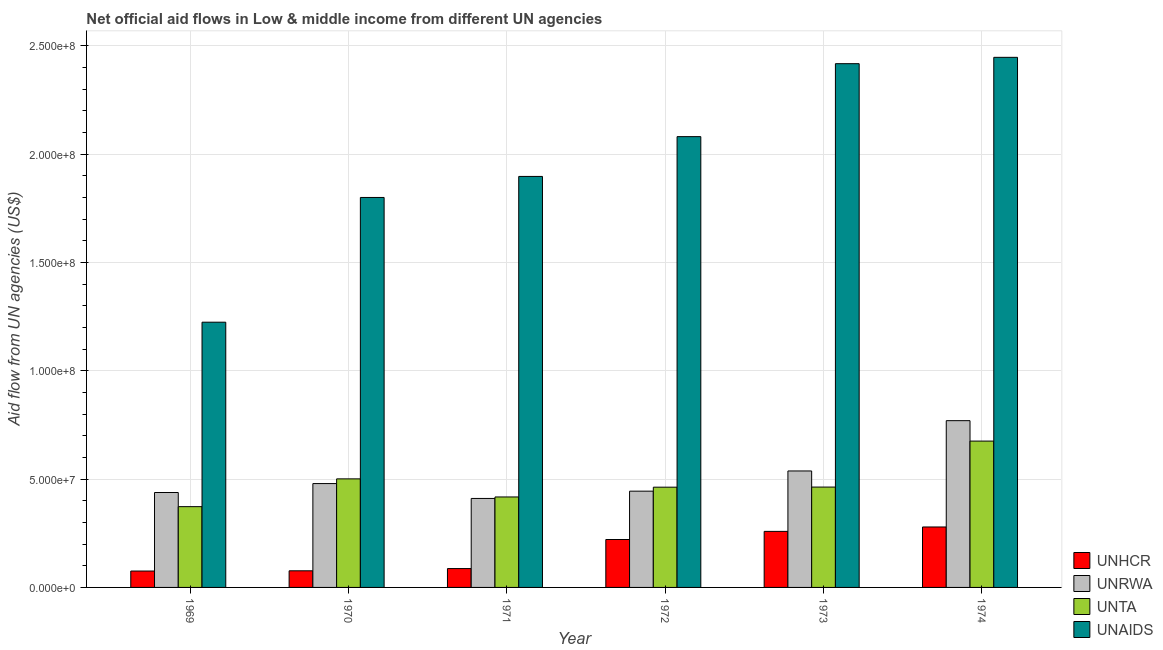How many bars are there on the 6th tick from the left?
Your answer should be compact. 4. What is the label of the 4th group of bars from the left?
Provide a succinct answer. 1972. What is the amount of aid given by unhcr in 1974?
Your answer should be very brief. 2.79e+07. Across all years, what is the maximum amount of aid given by unta?
Your answer should be compact. 6.75e+07. Across all years, what is the minimum amount of aid given by unhcr?
Provide a succinct answer. 7.56e+06. In which year was the amount of aid given by unrwa maximum?
Your response must be concise. 1974. What is the total amount of aid given by unrwa in the graph?
Your answer should be compact. 3.08e+08. What is the difference between the amount of aid given by unrwa in 1969 and that in 1974?
Provide a succinct answer. -3.32e+07. What is the difference between the amount of aid given by unrwa in 1974 and the amount of aid given by unta in 1969?
Offer a terse response. 3.32e+07. What is the average amount of aid given by unta per year?
Your response must be concise. 4.82e+07. In the year 1972, what is the difference between the amount of aid given by unaids and amount of aid given by unta?
Keep it short and to the point. 0. What is the ratio of the amount of aid given by unta in 1969 to that in 1971?
Your response must be concise. 0.89. What is the difference between the highest and the second highest amount of aid given by unaids?
Provide a succinct answer. 2.93e+06. What is the difference between the highest and the lowest amount of aid given by unhcr?
Offer a terse response. 2.03e+07. Is the sum of the amount of aid given by unhcr in 1970 and 1972 greater than the maximum amount of aid given by unaids across all years?
Provide a short and direct response. Yes. What does the 3rd bar from the left in 1969 represents?
Give a very brief answer. UNTA. What does the 3rd bar from the right in 1972 represents?
Provide a short and direct response. UNRWA. Is it the case that in every year, the sum of the amount of aid given by unhcr and amount of aid given by unrwa is greater than the amount of aid given by unta?
Ensure brevity in your answer.  Yes. Are the values on the major ticks of Y-axis written in scientific E-notation?
Your answer should be very brief. Yes. How many legend labels are there?
Offer a terse response. 4. What is the title of the graph?
Provide a short and direct response. Net official aid flows in Low & middle income from different UN agencies. What is the label or title of the Y-axis?
Your answer should be compact. Aid flow from UN agencies (US$). What is the Aid flow from UN agencies (US$) of UNHCR in 1969?
Your answer should be compact. 7.56e+06. What is the Aid flow from UN agencies (US$) of UNRWA in 1969?
Provide a short and direct response. 4.38e+07. What is the Aid flow from UN agencies (US$) of UNTA in 1969?
Keep it short and to the point. 3.73e+07. What is the Aid flow from UN agencies (US$) of UNAIDS in 1969?
Offer a terse response. 1.22e+08. What is the Aid flow from UN agencies (US$) of UNHCR in 1970?
Offer a terse response. 7.67e+06. What is the Aid flow from UN agencies (US$) of UNRWA in 1970?
Offer a very short reply. 4.79e+07. What is the Aid flow from UN agencies (US$) in UNTA in 1970?
Make the answer very short. 5.01e+07. What is the Aid flow from UN agencies (US$) in UNAIDS in 1970?
Ensure brevity in your answer.  1.80e+08. What is the Aid flow from UN agencies (US$) of UNHCR in 1971?
Your answer should be compact. 8.70e+06. What is the Aid flow from UN agencies (US$) in UNRWA in 1971?
Make the answer very short. 4.11e+07. What is the Aid flow from UN agencies (US$) of UNTA in 1971?
Give a very brief answer. 4.18e+07. What is the Aid flow from UN agencies (US$) in UNAIDS in 1971?
Your answer should be very brief. 1.90e+08. What is the Aid flow from UN agencies (US$) of UNHCR in 1972?
Your response must be concise. 2.21e+07. What is the Aid flow from UN agencies (US$) in UNRWA in 1972?
Provide a short and direct response. 4.44e+07. What is the Aid flow from UN agencies (US$) in UNTA in 1972?
Give a very brief answer. 4.63e+07. What is the Aid flow from UN agencies (US$) in UNAIDS in 1972?
Provide a short and direct response. 2.08e+08. What is the Aid flow from UN agencies (US$) in UNHCR in 1973?
Keep it short and to the point. 2.59e+07. What is the Aid flow from UN agencies (US$) of UNRWA in 1973?
Provide a succinct answer. 5.38e+07. What is the Aid flow from UN agencies (US$) in UNTA in 1973?
Your response must be concise. 4.63e+07. What is the Aid flow from UN agencies (US$) in UNAIDS in 1973?
Ensure brevity in your answer.  2.42e+08. What is the Aid flow from UN agencies (US$) of UNHCR in 1974?
Your answer should be very brief. 2.79e+07. What is the Aid flow from UN agencies (US$) of UNRWA in 1974?
Provide a short and direct response. 7.70e+07. What is the Aid flow from UN agencies (US$) in UNTA in 1974?
Keep it short and to the point. 6.75e+07. What is the Aid flow from UN agencies (US$) of UNAIDS in 1974?
Make the answer very short. 2.45e+08. Across all years, what is the maximum Aid flow from UN agencies (US$) in UNHCR?
Give a very brief answer. 2.79e+07. Across all years, what is the maximum Aid flow from UN agencies (US$) of UNRWA?
Offer a very short reply. 7.70e+07. Across all years, what is the maximum Aid flow from UN agencies (US$) in UNTA?
Your answer should be very brief. 6.75e+07. Across all years, what is the maximum Aid flow from UN agencies (US$) in UNAIDS?
Provide a short and direct response. 2.45e+08. Across all years, what is the minimum Aid flow from UN agencies (US$) in UNHCR?
Give a very brief answer. 7.56e+06. Across all years, what is the minimum Aid flow from UN agencies (US$) in UNRWA?
Ensure brevity in your answer.  4.11e+07. Across all years, what is the minimum Aid flow from UN agencies (US$) of UNTA?
Offer a very short reply. 3.73e+07. Across all years, what is the minimum Aid flow from UN agencies (US$) in UNAIDS?
Ensure brevity in your answer.  1.22e+08. What is the total Aid flow from UN agencies (US$) of UNHCR in the graph?
Your response must be concise. 9.98e+07. What is the total Aid flow from UN agencies (US$) of UNRWA in the graph?
Give a very brief answer. 3.08e+08. What is the total Aid flow from UN agencies (US$) in UNTA in the graph?
Your answer should be very brief. 2.89e+08. What is the total Aid flow from UN agencies (US$) of UNAIDS in the graph?
Keep it short and to the point. 1.19e+09. What is the difference between the Aid flow from UN agencies (US$) of UNRWA in 1969 and that in 1970?
Offer a very short reply. -4.13e+06. What is the difference between the Aid flow from UN agencies (US$) in UNTA in 1969 and that in 1970?
Your answer should be very brief. -1.28e+07. What is the difference between the Aid flow from UN agencies (US$) of UNAIDS in 1969 and that in 1970?
Offer a very short reply. -5.76e+07. What is the difference between the Aid flow from UN agencies (US$) of UNHCR in 1969 and that in 1971?
Make the answer very short. -1.14e+06. What is the difference between the Aid flow from UN agencies (US$) of UNRWA in 1969 and that in 1971?
Provide a succinct answer. 2.74e+06. What is the difference between the Aid flow from UN agencies (US$) in UNTA in 1969 and that in 1971?
Your answer should be compact. -4.47e+06. What is the difference between the Aid flow from UN agencies (US$) of UNAIDS in 1969 and that in 1971?
Your answer should be very brief. -6.73e+07. What is the difference between the Aid flow from UN agencies (US$) in UNHCR in 1969 and that in 1972?
Provide a short and direct response. -1.46e+07. What is the difference between the Aid flow from UN agencies (US$) of UNRWA in 1969 and that in 1972?
Make the answer very short. -6.20e+05. What is the difference between the Aid flow from UN agencies (US$) in UNTA in 1969 and that in 1972?
Ensure brevity in your answer.  -8.98e+06. What is the difference between the Aid flow from UN agencies (US$) in UNAIDS in 1969 and that in 1972?
Provide a succinct answer. -8.56e+07. What is the difference between the Aid flow from UN agencies (US$) in UNHCR in 1969 and that in 1973?
Provide a succinct answer. -1.83e+07. What is the difference between the Aid flow from UN agencies (US$) in UNRWA in 1969 and that in 1973?
Ensure brevity in your answer.  -9.95e+06. What is the difference between the Aid flow from UN agencies (US$) of UNTA in 1969 and that in 1973?
Your answer should be very brief. -9.03e+06. What is the difference between the Aid flow from UN agencies (US$) in UNAIDS in 1969 and that in 1973?
Your response must be concise. -1.19e+08. What is the difference between the Aid flow from UN agencies (US$) of UNHCR in 1969 and that in 1974?
Ensure brevity in your answer.  -2.03e+07. What is the difference between the Aid flow from UN agencies (US$) of UNRWA in 1969 and that in 1974?
Provide a short and direct response. -3.32e+07. What is the difference between the Aid flow from UN agencies (US$) of UNTA in 1969 and that in 1974?
Your response must be concise. -3.02e+07. What is the difference between the Aid flow from UN agencies (US$) of UNAIDS in 1969 and that in 1974?
Provide a short and direct response. -1.22e+08. What is the difference between the Aid flow from UN agencies (US$) in UNHCR in 1970 and that in 1971?
Make the answer very short. -1.03e+06. What is the difference between the Aid flow from UN agencies (US$) in UNRWA in 1970 and that in 1971?
Your answer should be compact. 6.87e+06. What is the difference between the Aid flow from UN agencies (US$) in UNTA in 1970 and that in 1971?
Your answer should be very brief. 8.35e+06. What is the difference between the Aid flow from UN agencies (US$) in UNAIDS in 1970 and that in 1971?
Your answer should be compact. -9.71e+06. What is the difference between the Aid flow from UN agencies (US$) of UNHCR in 1970 and that in 1972?
Make the answer very short. -1.44e+07. What is the difference between the Aid flow from UN agencies (US$) in UNRWA in 1970 and that in 1972?
Ensure brevity in your answer.  3.51e+06. What is the difference between the Aid flow from UN agencies (US$) in UNTA in 1970 and that in 1972?
Make the answer very short. 3.84e+06. What is the difference between the Aid flow from UN agencies (US$) of UNAIDS in 1970 and that in 1972?
Ensure brevity in your answer.  -2.81e+07. What is the difference between the Aid flow from UN agencies (US$) in UNHCR in 1970 and that in 1973?
Your answer should be compact. -1.82e+07. What is the difference between the Aid flow from UN agencies (US$) of UNRWA in 1970 and that in 1973?
Your answer should be compact. -5.82e+06. What is the difference between the Aid flow from UN agencies (US$) of UNTA in 1970 and that in 1973?
Keep it short and to the point. 3.79e+06. What is the difference between the Aid flow from UN agencies (US$) in UNAIDS in 1970 and that in 1973?
Offer a very short reply. -6.17e+07. What is the difference between the Aid flow from UN agencies (US$) in UNHCR in 1970 and that in 1974?
Keep it short and to the point. -2.02e+07. What is the difference between the Aid flow from UN agencies (US$) in UNRWA in 1970 and that in 1974?
Your answer should be compact. -2.90e+07. What is the difference between the Aid flow from UN agencies (US$) of UNTA in 1970 and that in 1974?
Ensure brevity in your answer.  -1.74e+07. What is the difference between the Aid flow from UN agencies (US$) of UNAIDS in 1970 and that in 1974?
Offer a very short reply. -6.47e+07. What is the difference between the Aid flow from UN agencies (US$) of UNHCR in 1971 and that in 1972?
Keep it short and to the point. -1.34e+07. What is the difference between the Aid flow from UN agencies (US$) of UNRWA in 1971 and that in 1972?
Offer a terse response. -3.36e+06. What is the difference between the Aid flow from UN agencies (US$) in UNTA in 1971 and that in 1972?
Offer a terse response. -4.51e+06. What is the difference between the Aid flow from UN agencies (US$) in UNAIDS in 1971 and that in 1972?
Ensure brevity in your answer.  -1.84e+07. What is the difference between the Aid flow from UN agencies (US$) of UNHCR in 1971 and that in 1973?
Keep it short and to the point. -1.72e+07. What is the difference between the Aid flow from UN agencies (US$) in UNRWA in 1971 and that in 1973?
Your answer should be very brief. -1.27e+07. What is the difference between the Aid flow from UN agencies (US$) in UNTA in 1971 and that in 1973?
Provide a succinct answer. -4.56e+06. What is the difference between the Aid flow from UN agencies (US$) of UNAIDS in 1971 and that in 1973?
Give a very brief answer. -5.20e+07. What is the difference between the Aid flow from UN agencies (US$) of UNHCR in 1971 and that in 1974?
Offer a terse response. -1.92e+07. What is the difference between the Aid flow from UN agencies (US$) of UNRWA in 1971 and that in 1974?
Offer a very short reply. -3.59e+07. What is the difference between the Aid flow from UN agencies (US$) of UNTA in 1971 and that in 1974?
Ensure brevity in your answer.  -2.58e+07. What is the difference between the Aid flow from UN agencies (US$) of UNAIDS in 1971 and that in 1974?
Your response must be concise. -5.50e+07. What is the difference between the Aid flow from UN agencies (US$) in UNHCR in 1972 and that in 1973?
Provide a succinct answer. -3.75e+06. What is the difference between the Aid flow from UN agencies (US$) of UNRWA in 1972 and that in 1973?
Offer a terse response. -9.33e+06. What is the difference between the Aid flow from UN agencies (US$) in UNTA in 1972 and that in 1973?
Provide a succinct answer. -5.00e+04. What is the difference between the Aid flow from UN agencies (US$) of UNAIDS in 1972 and that in 1973?
Give a very brief answer. -3.37e+07. What is the difference between the Aid flow from UN agencies (US$) in UNHCR in 1972 and that in 1974?
Provide a short and direct response. -5.79e+06. What is the difference between the Aid flow from UN agencies (US$) of UNRWA in 1972 and that in 1974?
Provide a short and direct response. -3.25e+07. What is the difference between the Aid flow from UN agencies (US$) in UNTA in 1972 and that in 1974?
Make the answer very short. -2.13e+07. What is the difference between the Aid flow from UN agencies (US$) of UNAIDS in 1972 and that in 1974?
Your answer should be very brief. -3.66e+07. What is the difference between the Aid flow from UN agencies (US$) in UNHCR in 1973 and that in 1974?
Provide a short and direct response. -2.04e+06. What is the difference between the Aid flow from UN agencies (US$) of UNRWA in 1973 and that in 1974?
Offer a very short reply. -2.32e+07. What is the difference between the Aid flow from UN agencies (US$) of UNTA in 1973 and that in 1974?
Your answer should be compact. -2.12e+07. What is the difference between the Aid flow from UN agencies (US$) of UNAIDS in 1973 and that in 1974?
Ensure brevity in your answer.  -2.93e+06. What is the difference between the Aid flow from UN agencies (US$) of UNHCR in 1969 and the Aid flow from UN agencies (US$) of UNRWA in 1970?
Your answer should be very brief. -4.04e+07. What is the difference between the Aid flow from UN agencies (US$) in UNHCR in 1969 and the Aid flow from UN agencies (US$) in UNTA in 1970?
Ensure brevity in your answer.  -4.25e+07. What is the difference between the Aid flow from UN agencies (US$) of UNHCR in 1969 and the Aid flow from UN agencies (US$) of UNAIDS in 1970?
Offer a terse response. -1.72e+08. What is the difference between the Aid flow from UN agencies (US$) in UNRWA in 1969 and the Aid flow from UN agencies (US$) in UNTA in 1970?
Your response must be concise. -6.30e+06. What is the difference between the Aid flow from UN agencies (US$) of UNRWA in 1969 and the Aid flow from UN agencies (US$) of UNAIDS in 1970?
Your answer should be compact. -1.36e+08. What is the difference between the Aid flow from UN agencies (US$) of UNTA in 1969 and the Aid flow from UN agencies (US$) of UNAIDS in 1970?
Your answer should be compact. -1.43e+08. What is the difference between the Aid flow from UN agencies (US$) of UNHCR in 1969 and the Aid flow from UN agencies (US$) of UNRWA in 1971?
Make the answer very short. -3.35e+07. What is the difference between the Aid flow from UN agencies (US$) of UNHCR in 1969 and the Aid flow from UN agencies (US$) of UNTA in 1971?
Provide a succinct answer. -3.42e+07. What is the difference between the Aid flow from UN agencies (US$) in UNHCR in 1969 and the Aid flow from UN agencies (US$) in UNAIDS in 1971?
Give a very brief answer. -1.82e+08. What is the difference between the Aid flow from UN agencies (US$) of UNRWA in 1969 and the Aid flow from UN agencies (US$) of UNTA in 1971?
Give a very brief answer. 2.05e+06. What is the difference between the Aid flow from UN agencies (US$) in UNRWA in 1969 and the Aid flow from UN agencies (US$) in UNAIDS in 1971?
Your answer should be very brief. -1.46e+08. What is the difference between the Aid flow from UN agencies (US$) in UNTA in 1969 and the Aid flow from UN agencies (US$) in UNAIDS in 1971?
Give a very brief answer. -1.52e+08. What is the difference between the Aid flow from UN agencies (US$) of UNHCR in 1969 and the Aid flow from UN agencies (US$) of UNRWA in 1972?
Make the answer very short. -3.69e+07. What is the difference between the Aid flow from UN agencies (US$) in UNHCR in 1969 and the Aid flow from UN agencies (US$) in UNTA in 1972?
Your answer should be compact. -3.87e+07. What is the difference between the Aid flow from UN agencies (US$) of UNHCR in 1969 and the Aid flow from UN agencies (US$) of UNAIDS in 1972?
Provide a short and direct response. -2.00e+08. What is the difference between the Aid flow from UN agencies (US$) in UNRWA in 1969 and the Aid flow from UN agencies (US$) in UNTA in 1972?
Give a very brief answer. -2.46e+06. What is the difference between the Aid flow from UN agencies (US$) of UNRWA in 1969 and the Aid flow from UN agencies (US$) of UNAIDS in 1972?
Your answer should be compact. -1.64e+08. What is the difference between the Aid flow from UN agencies (US$) of UNTA in 1969 and the Aid flow from UN agencies (US$) of UNAIDS in 1972?
Provide a short and direct response. -1.71e+08. What is the difference between the Aid flow from UN agencies (US$) of UNHCR in 1969 and the Aid flow from UN agencies (US$) of UNRWA in 1973?
Offer a very short reply. -4.62e+07. What is the difference between the Aid flow from UN agencies (US$) in UNHCR in 1969 and the Aid flow from UN agencies (US$) in UNTA in 1973?
Your answer should be compact. -3.88e+07. What is the difference between the Aid flow from UN agencies (US$) in UNHCR in 1969 and the Aid flow from UN agencies (US$) in UNAIDS in 1973?
Provide a short and direct response. -2.34e+08. What is the difference between the Aid flow from UN agencies (US$) in UNRWA in 1969 and the Aid flow from UN agencies (US$) in UNTA in 1973?
Provide a short and direct response. -2.51e+06. What is the difference between the Aid flow from UN agencies (US$) in UNRWA in 1969 and the Aid flow from UN agencies (US$) in UNAIDS in 1973?
Ensure brevity in your answer.  -1.98e+08. What is the difference between the Aid flow from UN agencies (US$) of UNTA in 1969 and the Aid flow from UN agencies (US$) of UNAIDS in 1973?
Offer a very short reply. -2.04e+08. What is the difference between the Aid flow from UN agencies (US$) of UNHCR in 1969 and the Aid flow from UN agencies (US$) of UNRWA in 1974?
Keep it short and to the point. -6.94e+07. What is the difference between the Aid flow from UN agencies (US$) in UNHCR in 1969 and the Aid flow from UN agencies (US$) in UNTA in 1974?
Offer a very short reply. -6.00e+07. What is the difference between the Aid flow from UN agencies (US$) of UNHCR in 1969 and the Aid flow from UN agencies (US$) of UNAIDS in 1974?
Give a very brief answer. -2.37e+08. What is the difference between the Aid flow from UN agencies (US$) in UNRWA in 1969 and the Aid flow from UN agencies (US$) in UNTA in 1974?
Keep it short and to the point. -2.37e+07. What is the difference between the Aid flow from UN agencies (US$) of UNRWA in 1969 and the Aid flow from UN agencies (US$) of UNAIDS in 1974?
Make the answer very short. -2.01e+08. What is the difference between the Aid flow from UN agencies (US$) of UNTA in 1969 and the Aid flow from UN agencies (US$) of UNAIDS in 1974?
Your response must be concise. -2.07e+08. What is the difference between the Aid flow from UN agencies (US$) in UNHCR in 1970 and the Aid flow from UN agencies (US$) in UNRWA in 1971?
Your answer should be very brief. -3.34e+07. What is the difference between the Aid flow from UN agencies (US$) of UNHCR in 1970 and the Aid flow from UN agencies (US$) of UNTA in 1971?
Your answer should be very brief. -3.41e+07. What is the difference between the Aid flow from UN agencies (US$) in UNHCR in 1970 and the Aid flow from UN agencies (US$) in UNAIDS in 1971?
Make the answer very short. -1.82e+08. What is the difference between the Aid flow from UN agencies (US$) of UNRWA in 1970 and the Aid flow from UN agencies (US$) of UNTA in 1971?
Provide a short and direct response. 6.18e+06. What is the difference between the Aid flow from UN agencies (US$) of UNRWA in 1970 and the Aid flow from UN agencies (US$) of UNAIDS in 1971?
Ensure brevity in your answer.  -1.42e+08. What is the difference between the Aid flow from UN agencies (US$) in UNTA in 1970 and the Aid flow from UN agencies (US$) in UNAIDS in 1971?
Ensure brevity in your answer.  -1.40e+08. What is the difference between the Aid flow from UN agencies (US$) of UNHCR in 1970 and the Aid flow from UN agencies (US$) of UNRWA in 1972?
Your response must be concise. -3.68e+07. What is the difference between the Aid flow from UN agencies (US$) of UNHCR in 1970 and the Aid flow from UN agencies (US$) of UNTA in 1972?
Offer a very short reply. -3.86e+07. What is the difference between the Aid flow from UN agencies (US$) of UNHCR in 1970 and the Aid flow from UN agencies (US$) of UNAIDS in 1972?
Provide a succinct answer. -2.00e+08. What is the difference between the Aid flow from UN agencies (US$) in UNRWA in 1970 and the Aid flow from UN agencies (US$) in UNTA in 1972?
Your answer should be very brief. 1.67e+06. What is the difference between the Aid flow from UN agencies (US$) in UNRWA in 1970 and the Aid flow from UN agencies (US$) in UNAIDS in 1972?
Your answer should be compact. -1.60e+08. What is the difference between the Aid flow from UN agencies (US$) in UNTA in 1970 and the Aid flow from UN agencies (US$) in UNAIDS in 1972?
Give a very brief answer. -1.58e+08. What is the difference between the Aid flow from UN agencies (US$) of UNHCR in 1970 and the Aid flow from UN agencies (US$) of UNRWA in 1973?
Provide a short and direct response. -4.61e+07. What is the difference between the Aid flow from UN agencies (US$) in UNHCR in 1970 and the Aid flow from UN agencies (US$) in UNTA in 1973?
Your answer should be compact. -3.86e+07. What is the difference between the Aid flow from UN agencies (US$) of UNHCR in 1970 and the Aid flow from UN agencies (US$) of UNAIDS in 1973?
Offer a terse response. -2.34e+08. What is the difference between the Aid flow from UN agencies (US$) in UNRWA in 1970 and the Aid flow from UN agencies (US$) in UNTA in 1973?
Your answer should be very brief. 1.62e+06. What is the difference between the Aid flow from UN agencies (US$) of UNRWA in 1970 and the Aid flow from UN agencies (US$) of UNAIDS in 1973?
Your response must be concise. -1.94e+08. What is the difference between the Aid flow from UN agencies (US$) of UNTA in 1970 and the Aid flow from UN agencies (US$) of UNAIDS in 1973?
Your answer should be very brief. -1.92e+08. What is the difference between the Aid flow from UN agencies (US$) in UNHCR in 1970 and the Aid flow from UN agencies (US$) in UNRWA in 1974?
Give a very brief answer. -6.93e+07. What is the difference between the Aid flow from UN agencies (US$) of UNHCR in 1970 and the Aid flow from UN agencies (US$) of UNTA in 1974?
Provide a short and direct response. -5.99e+07. What is the difference between the Aid flow from UN agencies (US$) of UNHCR in 1970 and the Aid flow from UN agencies (US$) of UNAIDS in 1974?
Give a very brief answer. -2.37e+08. What is the difference between the Aid flow from UN agencies (US$) in UNRWA in 1970 and the Aid flow from UN agencies (US$) in UNTA in 1974?
Your answer should be very brief. -1.96e+07. What is the difference between the Aid flow from UN agencies (US$) in UNRWA in 1970 and the Aid flow from UN agencies (US$) in UNAIDS in 1974?
Provide a succinct answer. -1.97e+08. What is the difference between the Aid flow from UN agencies (US$) in UNTA in 1970 and the Aid flow from UN agencies (US$) in UNAIDS in 1974?
Provide a short and direct response. -1.95e+08. What is the difference between the Aid flow from UN agencies (US$) of UNHCR in 1971 and the Aid flow from UN agencies (US$) of UNRWA in 1972?
Provide a succinct answer. -3.57e+07. What is the difference between the Aid flow from UN agencies (US$) of UNHCR in 1971 and the Aid flow from UN agencies (US$) of UNTA in 1972?
Your answer should be compact. -3.76e+07. What is the difference between the Aid flow from UN agencies (US$) in UNHCR in 1971 and the Aid flow from UN agencies (US$) in UNAIDS in 1972?
Make the answer very short. -1.99e+08. What is the difference between the Aid flow from UN agencies (US$) in UNRWA in 1971 and the Aid flow from UN agencies (US$) in UNTA in 1972?
Keep it short and to the point. -5.20e+06. What is the difference between the Aid flow from UN agencies (US$) of UNRWA in 1971 and the Aid flow from UN agencies (US$) of UNAIDS in 1972?
Ensure brevity in your answer.  -1.67e+08. What is the difference between the Aid flow from UN agencies (US$) in UNTA in 1971 and the Aid flow from UN agencies (US$) in UNAIDS in 1972?
Provide a succinct answer. -1.66e+08. What is the difference between the Aid flow from UN agencies (US$) of UNHCR in 1971 and the Aid flow from UN agencies (US$) of UNRWA in 1973?
Offer a very short reply. -4.50e+07. What is the difference between the Aid flow from UN agencies (US$) in UNHCR in 1971 and the Aid flow from UN agencies (US$) in UNTA in 1973?
Make the answer very short. -3.76e+07. What is the difference between the Aid flow from UN agencies (US$) of UNHCR in 1971 and the Aid flow from UN agencies (US$) of UNAIDS in 1973?
Make the answer very short. -2.33e+08. What is the difference between the Aid flow from UN agencies (US$) in UNRWA in 1971 and the Aid flow from UN agencies (US$) in UNTA in 1973?
Provide a succinct answer. -5.25e+06. What is the difference between the Aid flow from UN agencies (US$) in UNRWA in 1971 and the Aid flow from UN agencies (US$) in UNAIDS in 1973?
Ensure brevity in your answer.  -2.01e+08. What is the difference between the Aid flow from UN agencies (US$) of UNTA in 1971 and the Aid flow from UN agencies (US$) of UNAIDS in 1973?
Make the answer very short. -2.00e+08. What is the difference between the Aid flow from UN agencies (US$) in UNHCR in 1971 and the Aid flow from UN agencies (US$) in UNRWA in 1974?
Offer a terse response. -6.83e+07. What is the difference between the Aid flow from UN agencies (US$) in UNHCR in 1971 and the Aid flow from UN agencies (US$) in UNTA in 1974?
Provide a short and direct response. -5.88e+07. What is the difference between the Aid flow from UN agencies (US$) in UNHCR in 1971 and the Aid flow from UN agencies (US$) in UNAIDS in 1974?
Your response must be concise. -2.36e+08. What is the difference between the Aid flow from UN agencies (US$) of UNRWA in 1971 and the Aid flow from UN agencies (US$) of UNTA in 1974?
Offer a very short reply. -2.65e+07. What is the difference between the Aid flow from UN agencies (US$) of UNRWA in 1971 and the Aid flow from UN agencies (US$) of UNAIDS in 1974?
Your response must be concise. -2.04e+08. What is the difference between the Aid flow from UN agencies (US$) in UNTA in 1971 and the Aid flow from UN agencies (US$) in UNAIDS in 1974?
Offer a terse response. -2.03e+08. What is the difference between the Aid flow from UN agencies (US$) in UNHCR in 1972 and the Aid flow from UN agencies (US$) in UNRWA in 1973?
Your response must be concise. -3.16e+07. What is the difference between the Aid flow from UN agencies (US$) of UNHCR in 1972 and the Aid flow from UN agencies (US$) of UNTA in 1973?
Your response must be concise. -2.42e+07. What is the difference between the Aid flow from UN agencies (US$) of UNHCR in 1972 and the Aid flow from UN agencies (US$) of UNAIDS in 1973?
Provide a succinct answer. -2.20e+08. What is the difference between the Aid flow from UN agencies (US$) in UNRWA in 1972 and the Aid flow from UN agencies (US$) in UNTA in 1973?
Your answer should be compact. -1.89e+06. What is the difference between the Aid flow from UN agencies (US$) of UNRWA in 1972 and the Aid flow from UN agencies (US$) of UNAIDS in 1973?
Keep it short and to the point. -1.97e+08. What is the difference between the Aid flow from UN agencies (US$) in UNTA in 1972 and the Aid flow from UN agencies (US$) in UNAIDS in 1973?
Provide a succinct answer. -1.95e+08. What is the difference between the Aid flow from UN agencies (US$) in UNHCR in 1972 and the Aid flow from UN agencies (US$) in UNRWA in 1974?
Offer a terse response. -5.48e+07. What is the difference between the Aid flow from UN agencies (US$) in UNHCR in 1972 and the Aid flow from UN agencies (US$) in UNTA in 1974?
Your answer should be very brief. -4.54e+07. What is the difference between the Aid flow from UN agencies (US$) in UNHCR in 1972 and the Aid flow from UN agencies (US$) in UNAIDS in 1974?
Your response must be concise. -2.23e+08. What is the difference between the Aid flow from UN agencies (US$) of UNRWA in 1972 and the Aid flow from UN agencies (US$) of UNTA in 1974?
Offer a very short reply. -2.31e+07. What is the difference between the Aid flow from UN agencies (US$) of UNRWA in 1972 and the Aid flow from UN agencies (US$) of UNAIDS in 1974?
Provide a short and direct response. -2.00e+08. What is the difference between the Aid flow from UN agencies (US$) in UNTA in 1972 and the Aid flow from UN agencies (US$) in UNAIDS in 1974?
Offer a terse response. -1.98e+08. What is the difference between the Aid flow from UN agencies (US$) of UNHCR in 1973 and the Aid flow from UN agencies (US$) of UNRWA in 1974?
Offer a very short reply. -5.11e+07. What is the difference between the Aid flow from UN agencies (US$) in UNHCR in 1973 and the Aid flow from UN agencies (US$) in UNTA in 1974?
Ensure brevity in your answer.  -4.17e+07. What is the difference between the Aid flow from UN agencies (US$) in UNHCR in 1973 and the Aid flow from UN agencies (US$) in UNAIDS in 1974?
Your response must be concise. -2.19e+08. What is the difference between the Aid flow from UN agencies (US$) of UNRWA in 1973 and the Aid flow from UN agencies (US$) of UNTA in 1974?
Offer a very short reply. -1.38e+07. What is the difference between the Aid flow from UN agencies (US$) in UNRWA in 1973 and the Aid flow from UN agencies (US$) in UNAIDS in 1974?
Provide a short and direct response. -1.91e+08. What is the difference between the Aid flow from UN agencies (US$) of UNTA in 1973 and the Aid flow from UN agencies (US$) of UNAIDS in 1974?
Your answer should be compact. -1.98e+08. What is the average Aid flow from UN agencies (US$) in UNHCR per year?
Your answer should be very brief. 1.66e+07. What is the average Aid flow from UN agencies (US$) in UNRWA per year?
Ensure brevity in your answer.  5.13e+07. What is the average Aid flow from UN agencies (US$) of UNTA per year?
Keep it short and to the point. 4.82e+07. What is the average Aid flow from UN agencies (US$) of UNAIDS per year?
Your answer should be very brief. 1.98e+08. In the year 1969, what is the difference between the Aid flow from UN agencies (US$) in UNHCR and Aid flow from UN agencies (US$) in UNRWA?
Keep it short and to the point. -3.62e+07. In the year 1969, what is the difference between the Aid flow from UN agencies (US$) in UNHCR and Aid flow from UN agencies (US$) in UNTA?
Keep it short and to the point. -2.97e+07. In the year 1969, what is the difference between the Aid flow from UN agencies (US$) of UNHCR and Aid flow from UN agencies (US$) of UNAIDS?
Your answer should be very brief. -1.15e+08. In the year 1969, what is the difference between the Aid flow from UN agencies (US$) in UNRWA and Aid flow from UN agencies (US$) in UNTA?
Offer a terse response. 6.52e+06. In the year 1969, what is the difference between the Aid flow from UN agencies (US$) in UNRWA and Aid flow from UN agencies (US$) in UNAIDS?
Keep it short and to the point. -7.86e+07. In the year 1969, what is the difference between the Aid flow from UN agencies (US$) in UNTA and Aid flow from UN agencies (US$) in UNAIDS?
Provide a short and direct response. -8.51e+07. In the year 1970, what is the difference between the Aid flow from UN agencies (US$) of UNHCR and Aid flow from UN agencies (US$) of UNRWA?
Offer a very short reply. -4.03e+07. In the year 1970, what is the difference between the Aid flow from UN agencies (US$) of UNHCR and Aid flow from UN agencies (US$) of UNTA?
Your answer should be very brief. -4.24e+07. In the year 1970, what is the difference between the Aid flow from UN agencies (US$) in UNHCR and Aid flow from UN agencies (US$) in UNAIDS?
Offer a very short reply. -1.72e+08. In the year 1970, what is the difference between the Aid flow from UN agencies (US$) in UNRWA and Aid flow from UN agencies (US$) in UNTA?
Provide a short and direct response. -2.17e+06. In the year 1970, what is the difference between the Aid flow from UN agencies (US$) in UNRWA and Aid flow from UN agencies (US$) in UNAIDS?
Give a very brief answer. -1.32e+08. In the year 1970, what is the difference between the Aid flow from UN agencies (US$) in UNTA and Aid flow from UN agencies (US$) in UNAIDS?
Your response must be concise. -1.30e+08. In the year 1971, what is the difference between the Aid flow from UN agencies (US$) of UNHCR and Aid flow from UN agencies (US$) of UNRWA?
Give a very brief answer. -3.24e+07. In the year 1971, what is the difference between the Aid flow from UN agencies (US$) in UNHCR and Aid flow from UN agencies (US$) in UNTA?
Your response must be concise. -3.30e+07. In the year 1971, what is the difference between the Aid flow from UN agencies (US$) in UNHCR and Aid flow from UN agencies (US$) in UNAIDS?
Give a very brief answer. -1.81e+08. In the year 1971, what is the difference between the Aid flow from UN agencies (US$) of UNRWA and Aid flow from UN agencies (US$) of UNTA?
Your response must be concise. -6.90e+05. In the year 1971, what is the difference between the Aid flow from UN agencies (US$) of UNRWA and Aid flow from UN agencies (US$) of UNAIDS?
Give a very brief answer. -1.49e+08. In the year 1971, what is the difference between the Aid flow from UN agencies (US$) of UNTA and Aid flow from UN agencies (US$) of UNAIDS?
Offer a terse response. -1.48e+08. In the year 1972, what is the difference between the Aid flow from UN agencies (US$) in UNHCR and Aid flow from UN agencies (US$) in UNRWA?
Offer a terse response. -2.23e+07. In the year 1972, what is the difference between the Aid flow from UN agencies (US$) of UNHCR and Aid flow from UN agencies (US$) of UNTA?
Offer a terse response. -2.42e+07. In the year 1972, what is the difference between the Aid flow from UN agencies (US$) of UNHCR and Aid flow from UN agencies (US$) of UNAIDS?
Provide a succinct answer. -1.86e+08. In the year 1972, what is the difference between the Aid flow from UN agencies (US$) of UNRWA and Aid flow from UN agencies (US$) of UNTA?
Offer a very short reply. -1.84e+06. In the year 1972, what is the difference between the Aid flow from UN agencies (US$) in UNRWA and Aid flow from UN agencies (US$) in UNAIDS?
Provide a short and direct response. -1.64e+08. In the year 1972, what is the difference between the Aid flow from UN agencies (US$) in UNTA and Aid flow from UN agencies (US$) in UNAIDS?
Provide a short and direct response. -1.62e+08. In the year 1973, what is the difference between the Aid flow from UN agencies (US$) of UNHCR and Aid flow from UN agencies (US$) of UNRWA?
Provide a short and direct response. -2.79e+07. In the year 1973, what is the difference between the Aid flow from UN agencies (US$) of UNHCR and Aid flow from UN agencies (US$) of UNTA?
Your answer should be very brief. -2.04e+07. In the year 1973, what is the difference between the Aid flow from UN agencies (US$) in UNHCR and Aid flow from UN agencies (US$) in UNAIDS?
Provide a short and direct response. -2.16e+08. In the year 1973, what is the difference between the Aid flow from UN agencies (US$) of UNRWA and Aid flow from UN agencies (US$) of UNTA?
Provide a short and direct response. 7.44e+06. In the year 1973, what is the difference between the Aid flow from UN agencies (US$) of UNRWA and Aid flow from UN agencies (US$) of UNAIDS?
Give a very brief answer. -1.88e+08. In the year 1973, what is the difference between the Aid flow from UN agencies (US$) in UNTA and Aid flow from UN agencies (US$) in UNAIDS?
Make the answer very short. -1.95e+08. In the year 1974, what is the difference between the Aid flow from UN agencies (US$) in UNHCR and Aid flow from UN agencies (US$) in UNRWA?
Provide a succinct answer. -4.91e+07. In the year 1974, what is the difference between the Aid flow from UN agencies (US$) of UNHCR and Aid flow from UN agencies (US$) of UNTA?
Your answer should be very brief. -3.96e+07. In the year 1974, what is the difference between the Aid flow from UN agencies (US$) in UNHCR and Aid flow from UN agencies (US$) in UNAIDS?
Your answer should be compact. -2.17e+08. In the year 1974, what is the difference between the Aid flow from UN agencies (US$) of UNRWA and Aid flow from UN agencies (US$) of UNTA?
Provide a short and direct response. 9.43e+06. In the year 1974, what is the difference between the Aid flow from UN agencies (US$) of UNRWA and Aid flow from UN agencies (US$) of UNAIDS?
Ensure brevity in your answer.  -1.68e+08. In the year 1974, what is the difference between the Aid flow from UN agencies (US$) in UNTA and Aid flow from UN agencies (US$) in UNAIDS?
Offer a terse response. -1.77e+08. What is the ratio of the Aid flow from UN agencies (US$) of UNHCR in 1969 to that in 1970?
Your answer should be compact. 0.99. What is the ratio of the Aid flow from UN agencies (US$) of UNRWA in 1969 to that in 1970?
Make the answer very short. 0.91. What is the ratio of the Aid flow from UN agencies (US$) of UNTA in 1969 to that in 1970?
Your answer should be compact. 0.74. What is the ratio of the Aid flow from UN agencies (US$) in UNAIDS in 1969 to that in 1970?
Offer a very short reply. 0.68. What is the ratio of the Aid flow from UN agencies (US$) of UNHCR in 1969 to that in 1971?
Provide a succinct answer. 0.87. What is the ratio of the Aid flow from UN agencies (US$) of UNRWA in 1969 to that in 1971?
Your answer should be very brief. 1.07. What is the ratio of the Aid flow from UN agencies (US$) of UNTA in 1969 to that in 1971?
Provide a succinct answer. 0.89. What is the ratio of the Aid flow from UN agencies (US$) of UNAIDS in 1969 to that in 1971?
Provide a short and direct response. 0.65. What is the ratio of the Aid flow from UN agencies (US$) of UNHCR in 1969 to that in 1972?
Your answer should be very brief. 0.34. What is the ratio of the Aid flow from UN agencies (US$) in UNRWA in 1969 to that in 1972?
Your answer should be very brief. 0.99. What is the ratio of the Aid flow from UN agencies (US$) of UNTA in 1969 to that in 1972?
Provide a short and direct response. 0.81. What is the ratio of the Aid flow from UN agencies (US$) in UNAIDS in 1969 to that in 1972?
Make the answer very short. 0.59. What is the ratio of the Aid flow from UN agencies (US$) in UNHCR in 1969 to that in 1973?
Offer a terse response. 0.29. What is the ratio of the Aid flow from UN agencies (US$) of UNRWA in 1969 to that in 1973?
Your answer should be compact. 0.81. What is the ratio of the Aid flow from UN agencies (US$) in UNTA in 1969 to that in 1973?
Provide a succinct answer. 0.81. What is the ratio of the Aid flow from UN agencies (US$) in UNAIDS in 1969 to that in 1973?
Provide a succinct answer. 0.51. What is the ratio of the Aid flow from UN agencies (US$) in UNHCR in 1969 to that in 1974?
Provide a short and direct response. 0.27. What is the ratio of the Aid flow from UN agencies (US$) in UNRWA in 1969 to that in 1974?
Provide a short and direct response. 0.57. What is the ratio of the Aid flow from UN agencies (US$) of UNTA in 1969 to that in 1974?
Keep it short and to the point. 0.55. What is the ratio of the Aid flow from UN agencies (US$) in UNAIDS in 1969 to that in 1974?
Ensure brevity in your answer.  0.5. What is the ratio of the Aid flow from UN agencies (US$) in UNHCR in 1970 to that in 1971?
Keep it short and to the point. 0.88. What is the ratio of the Aid flow from UN agencies (US$) in UNRWA in 1970 to that in 1971?
Make the answer very short. 1.17. What is the ratio of the Aid flow from UN agencies (US$) of UNAIDS in 1970 to that in 1971?
Ensure brevity in your answer.  0.95. What is the ratio of the Aid flow from UN agencies (US$) in UNHCR in 1970 to that in 1972?
Offer a terse response. 0.35. What is the ratio of the Aid flow from UN agencies (US$) in UNRWA in 1970 to that in 1972?
Give a very brief answer. 1.08. What is the ratio of the Aid flow from UN agencies (US$) of UNTA in 1970 to that in 1972?
Ensure brevity in your answer.  1.08. What is the ratio of the Aid flow from UN agencies (US$) in UNAIDS in 1970 to that in 1972?
Give a very brief answer. 0.87. What is the ratio of the Aid flow from UN agencies (US$) of UNHCR in 1970 to that in 1973?
Your answer should be very brief. 0.3. What is the ratio of the Aid flow from UN agencies (US$) in UNRWA in 1970 to that in 1973?
Your answer should be compact. 0.89. What is the ratio of the Aid flow from UN agencies (US$) in UNTA in 1970 to that in 1973?
Make the answer very short. 1.08. What is the ratio of the Aid flow from UN agencies (US$) of UNAIDS in 1970 to that in 1973?
Provide a short and direct response. 0.74. What is the ratio of the Aid flow from UN agencies (US$) of UNHCR in 1970 to that in 1974?
Provide a short and direct response. 0.27. What is the ratio of the Aid flow from UN agencies (US$) of UNRWA in 1970 to that in 1974?
Your answer should be very brief. 0.62. What is the ratio of the Aid flow from UN agencies (US$) of UNTA in 1970 to that in 1974?
Make the answer very short. 0.74. What is the ratio of the Aid flow from UN agencies (US$) in UNAIDS in 1970 to that in 1974?
Give a very brief answer. 0.74. What is the ratio of the Aid flow from UN agencies (US$) of UNHCR in 1971 to that in 1972?
Your answer should be compact. 0.39. What is the ratio of the Aid flow from UN agencies (US$) in UNRWA in 1971 to that in 1972?
Offer a terse response. 0.92. What is the ratio of the Aid flow from UN agencies (US$) of UNTA in 1971 to that in 1972?
Your answer should be very brief. 0.9. What is the ratio of the Aid flow from UN agencies (US$) in UNAIDS in 1971 to that in 1972?
Offer a very short reply. 0.91. What is the ratio of the Aid flow from UN agencies (US$) of UNHCR in 1971 to that in 1973?
Make the answer very short. 0.34. What is the ratio of the Aid flow from UN agencies (US$) in UNRWA in 1971 to that in 1973?
Your response must be concise. 0.76. What is the ratio of the Aid flow from UN agencies (US$) in UNTA in 1971 to that in 1973?
Provide a short and direct response. 0.9. What is the ratio of the Aid flow from UN agencies (US$) of UNAIDS in 1971 to that in 1973?
Provide a succinct answer. 0.78. What is the ratio of the Aid flow from UN agencies (US$) of UNHCR in 1971 to that in 1974?
Ensure brevity in your answer.  0.31. What is the ratio of the Aid flow from UN agencies (US$) of UNRWA in 1971 to that in 1974?
Offer a very short reply. 0.53. What is the ratio of the Aid flow from UN agencies (US$) of UNTA in 1971 to that in 1974?
Your answer should be compact. 0.62. What is the ratio of the Aid flow from UN agencies (US$) of UNAIDS in 1971 to that in 1974?
Offer a terse response. 0.78. What is the ratio of the Aid flow from UN agencies (US$) in UNHCR in 1972 to that in 1973?
Ensure brevity in your answer.  0.85. What is the ratio of the Aid flow from UN agencies (US$) in UNRWA in 1972 to that in 1973?
Your answer should be compact. 0.83. What is the ratio of the Aid flow from UN agencies (US$) of UNAIDS in 1972 to that in 1973?
Your answer should be very brief. 0.86. What is the ratio of the Aid flow from UN agencies (US$) in UNHCR in 1972 to that in 1974?
Offer a terse response. 0.79. What is the ratio of the Aid flow from UN agencies (US$) in UNRWA in 1972 to that in 1974?
Offer a very short reply. 0.58. What is the ratio of the Aid flow from UN agencies (US$) in UNTA in 1972 to that in 1974?
Ensure brevity in your answer.  0.69. What is the ratio of the Aid flow from UN agencies (US$) of UNAIDS in 1972 to that in 1974?
Your answer should be very brief. 0.85. What is the ratio of the Aid flow from UN agencies (US$) of UNHCR in 1973 to that in 1974?
Give a very brief answer. 0.93. What is the ratio of the Aid flow from UN agencies (US$) of UNRWA in 1973 to that in 1974?
Provide a succinct answer. 0.7. What is the ratio of the Aid flow from UN agencies (US$) of UNTA in 1973 to that in 1974?
Provide a succinct answer. 0.69. What is the difference between the highest and the second highest Aid flow from UN agencies (US$) of UNHCR?
Provide a short and direct response. 2.04e+06. What is the difference between the highest and the second highest Aid flow from UN agencies (US$) of UNRWA?
Make the answer very short. 2.32e+07. What is the difference between the highest and the second highest Aid flow from UN agencies (US$) of UNTA?
Ensure brevity in your answer.  1.74e+07. What is the difference between the highest and the second highest Aid flow from UN agencies (US$) in UNAIDS?
Your answer should be compact. 2.93e+06. What is the difference between the highest and the lowest Aid flow from UN agencies (US$) in UNHCR?
Provide a short and direct response. 2.03e+07. What is the difference between the highest and the lowest Aid flow from UN agencies (US$) of UNRWA?
Your response must be concise. 3.59e+07. What is the difference between the highest and the lowest Aid flow from UN agencies (US$) in UNTA?
Your answer should be very brief. 3.02e+07. What is the difference between the highest and the lowest Aid flow from UN agencies (US$) in UNAIDS?
Your answer should be very brief. 1.22e+08. 